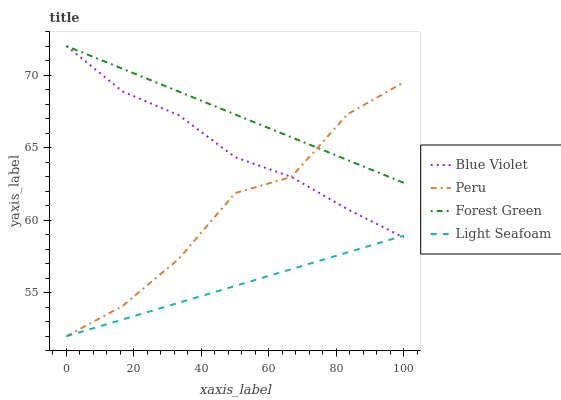Does Light Seafoam have the minimum area under the curve?
Answer yes or no. Yes. Does Forest Green have the maximum area under the curve?
Answer yes or no. Yes. Does Peru have the minimum area under the curve?
Answer yes or no. No. Does Peru have the maximum area under the curve?
Answer yes or no. No. Is Light Seafoam the smoothest?
Answer yes or no. Yes. Is Peru the roughest?
Answer yes or no. Yes. Is Peru the smoothest?
Answer yes or no. No. Is Light Seafoam the roughest?
Answer yes or no. No. Does Light Seafoam have the lowest value?
Answer yes or no. Yes. Does Blue Violet have the lowest value?
Answer yes or no. No. Does Blue Violet have the highest value?
Answer yes or no. Yes. Does Peru have the highest value?
Answer yes or no. No. Is Light Seafoam less than Forest Green?
Answer yes or no. Yes. Is Forest Green greater than Light Seafoam?
Answer yes or no. Yes. Does Peru intersect Forest Green?
Answer yes or no. Yes. Is Peru less than Forest Green?
Answer yes or no. No. Is Peru greater than Forest Green?
Answer yes or no. No. Does Light Seafoam intersect Forest Green?
Answer yes or no. No. 